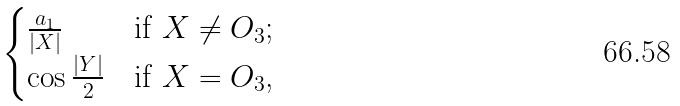<formula> <loc_0><loc_0><loc_500><loc_500>\begin{cases} \frac { a _ { 1 } } { \left | X \right | } & \text {if $X \neq O_{3}$;} \\ \cos \frac { \left | Y \right | } { 2 } & \text {if $X= O_{3}$,} \\ \end{cases}</formula> 